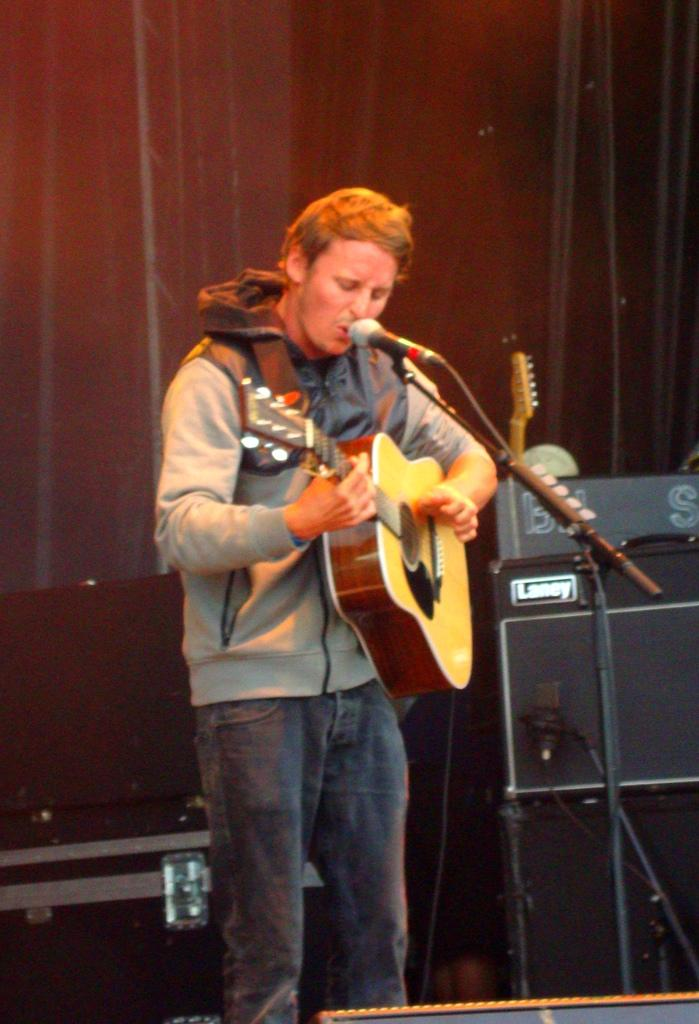What is the main subject of the image? There is a man in the image. What is the man doing in the image? The man is standing, playing a guitar, and singing into a microphone. What type of verse is the man reciting in the image? There is no verse or recitation mentioned in the image; the man is singing into a microphone. What is the man painting on the canvas in the image? There is no canvas or painting activity present in the image; the man is playing a guitar and singing. 